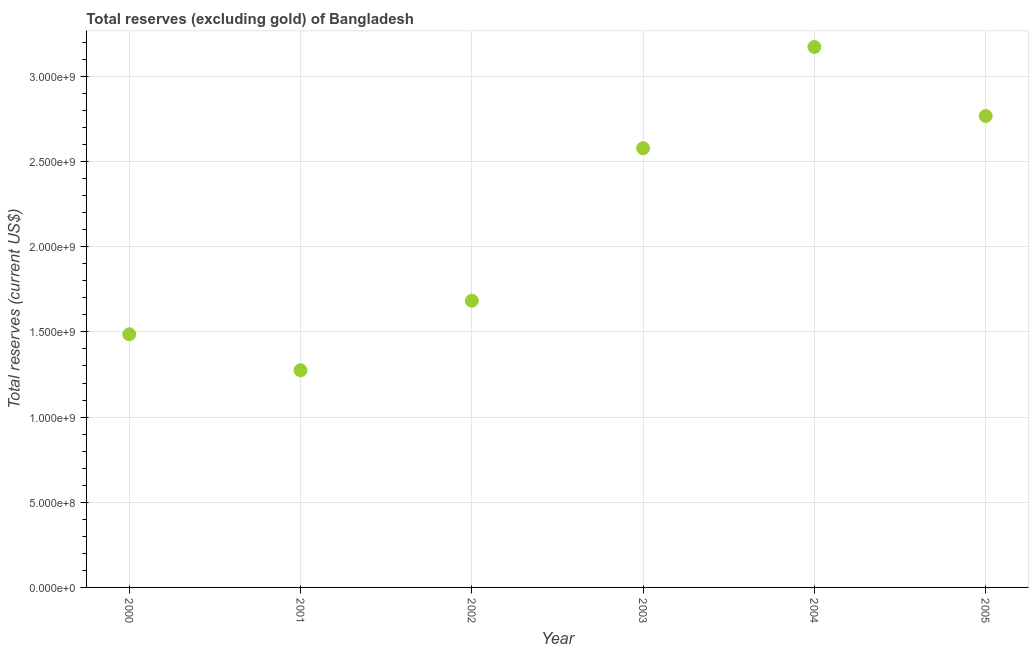What is the total reserves (excluding gold) in 2004?
Give a very brief answer. 3.17e+09. Across all years, what is the maximum total reserves (excluding gold)?
Offer a terse response. 3.17e+09. Across all years, what is the minimum total reserves (excluding gold)?
Provide a short and direct response. 1.28e+09. What is the sum of the total reserves (excluding gold)?
Your answer should be compact. 1.30e+1. What is the difference between the total reserves (excluding gold) in 2000 and 2001?
Offer a terse response. 2.11e+08. What is the average total reserves (excluding gold) per year?
Your answer should be very brief. 2.16e+09. What is the median total reserves (excluding gold)?
Offer a very short reply. 2.13e+09. Do a majority of the years between 2004 and 2003 (inclusive) have total reserves (excluding gold) greater than 900000000 US$?
Your response must be concise. No. What is the ratio of the total reserves (excluding gold) in 2001 to that in 2004?
Provide a succinct answer. 0.4. Is the difference between the total reserves (excluding gold) in 2001 and 2004 greater than the difference between any two years?
Ensure brevity in your answer.  Yes. What is the difference between the highest and the second highest total reserves (excluding gold)?
Provide a short and direct response. 4.05e+08. Is the sum of the total reserves (excluding gold) in 2003 and 2004 greater than the maximum total reserves (excluding gold) across all years?
Provide a short and direct response. Yes. What is the difference between the highest and the lowest total reserves (excluding gold)?
Provide a succinct answer. 1.90e+09. In how many years, is the total reserves (excluding gold) greater than the average total reserves (excluding gold) taken over all years?
Offer a terse response. 3. Does the total reserves (excluding gold) monotonically increase over the years?
Your response must be concise. No. How many dotlines are there?
Make the answer very short. 1. What is the difference between two consecutive major ticks on the Y-axis?
Provide a succinct answer. 5.00e+08. What is the title of the graph?
Make the answer very short. Total reserves (excluding gold) of Bangladesh. What is the label or title of the Y-axis?
Ensure brevity in your answer.  Total reserves (current US$). What is the Total reserves (current US$) in 2000?
Provide a succinct answer. 1.49e+09. What is the Total reserves (current US$) in 2001?
Your answer should be compact. 1.28e+09. What is the Total reserves (current US$) in 2002?
Your response must be concise. 1.68e+09. What is the Total reserves (current US$) in 2003?
Offer a terse response. 2.58e+09. What is the Total reserves (current US$) in 2004?
Give a very brief answer. 3.17e+09. What is the Total reserves (current US$) in 2005?
Give a very brief answer. 2.77e+09. What is the difference between the Total reserves (current US$) in 2000 and 2001?
Provide a succinct answer. 2.11e+08. What is the difference between the Total reserves (current US$) in 2000 and 2002?
Offer a terse response. -1.97e+08. What is the difference between the Total reserves (current US$) in 2000 and 2003?
Your answer should be very brief. -1.09e+09. What is the difference between the Total reserves (current US$) in 2000 and 2004?
Provide a short and direct response. -1.69e+09. What is the difference between the Total reserves (current US$) in 2000 and 2005?
Provide a succinct answer. -1.28e+09. What is the difference between the Total reserves (current US$) in 2001 and 2002?
Provide a short and direct response. -4.08e+08. What is the difference between the Total reserves (current US$) in 2001 and 2003?
Keep it short and to the point. -1.30e+09. What is the difference between the Total reserves (current US$) in 2001 and 2004?
Offer a very short reply. -1.90e+09. What is the difference between the Total reserves (current US$) in 2001 and 2005?
Offer a very short reply. -1.49e+09. What is the difference between the Total reserves (current US$) in 2002 and 2003?
Your response must be concise. -8.95e+08. What is the difference between the Total reserves (current US$) in 2002 and 2004?
Keep it short and to the point. -1.49e+09. What is the difference between the Total reserves (current US$) in 2002 and 2005?
Give a very brief answer. -1.08e+09. What is the difference between the Total reserves (current US$) in 2003 and 2004?
Provide a short and direct response. -5.95e+08. What is the difference between the Total reserves (current US$) in 2003 and 2005?
Provide a short and direct response. -1.89e+08. What is the difference between the Total reserves (current US$) in 2004 and 2005?
Ensure brevity in your answer.  4.05e+08. What is the ratio of the Total reserves (current US$) in 2000 to that in 2001?
Offer a terse response. 1.17. What is the ratio of the Total reserves (current US$) in 2000 to that in 2002?
Your answer should be compact. 0.88. What is the ratio of the Total reserves (current US$) in 2000 to that in 2003?
Provide a short and direct response. 0.58. What is the ratio of the Total reserves (current US$) in 2000 to that in 2004?
Keep it short and to the point. 0.47. What is the ratio of the Total reserves (current US$) in 2000 to that in 2005?
Offer a terse response. 0.54. What is the ratio of the Total reserves (current US$) in 2001 to that in 2002?
Keep it short and to the point. 0.76. What is the ratio of the Total reserves (current US$) in 2001 to that in 2003?
Make the answer very short. 0.49. What is the ratio of the Total reserves (current US$) in 2001 to that in 2004?
Ensure brevity in your answer.  0.4. What is the ratio of the Total reserves (current US$) in 2001 to that in 2005?
Offer a very short reply. 0.46. What is the ratio of the Total reserves (current US$) in 2002 to that in 2003?
Give a very brief answer. 0.65. What is the ratio of the Total reserves (current US$) in 2002 to that in 2004?
Provide a short and direct response. 0.53. What is the ratio of the Total reserves (current US$) in 2002 to that in 2005?
Ensure brevity in your answer.  0.61. What is the ratio of the Total reserves (current US$) in 2003 to that in 2004?
Offer a terse response. 0.81. What is the ratio of the Total reserves (current US$) in 2003 to that in 2005?
Your response must be concise. 0.93. What is the ratio of the Total reserves (current US$) in 2004 to that in 2005?
Give a very brief answer. 1.15. 